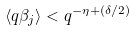<formula> <loc_0><loc_0><loc_500><loc_500>\langle q \beta _ { j } \rangle < q ^ { - \eta + ( \delta / 2 ) }</formula> 